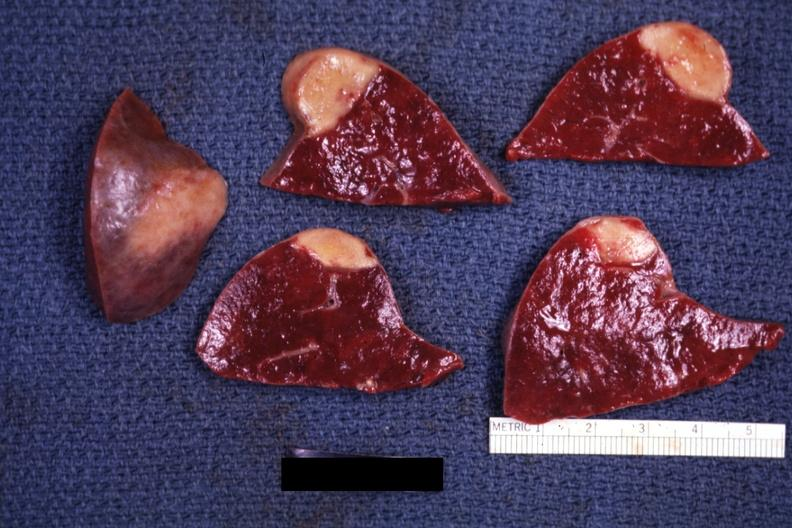s hematologic present?
Answer the question using a single word or phrase. Yes 